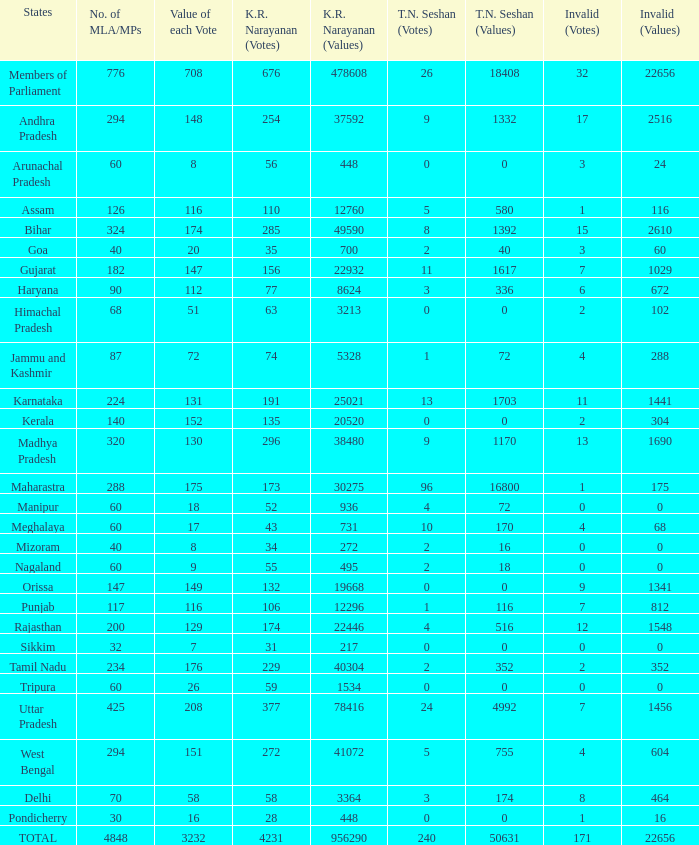Name the kr narayanan votes for values being 936 for kr 52.0. 